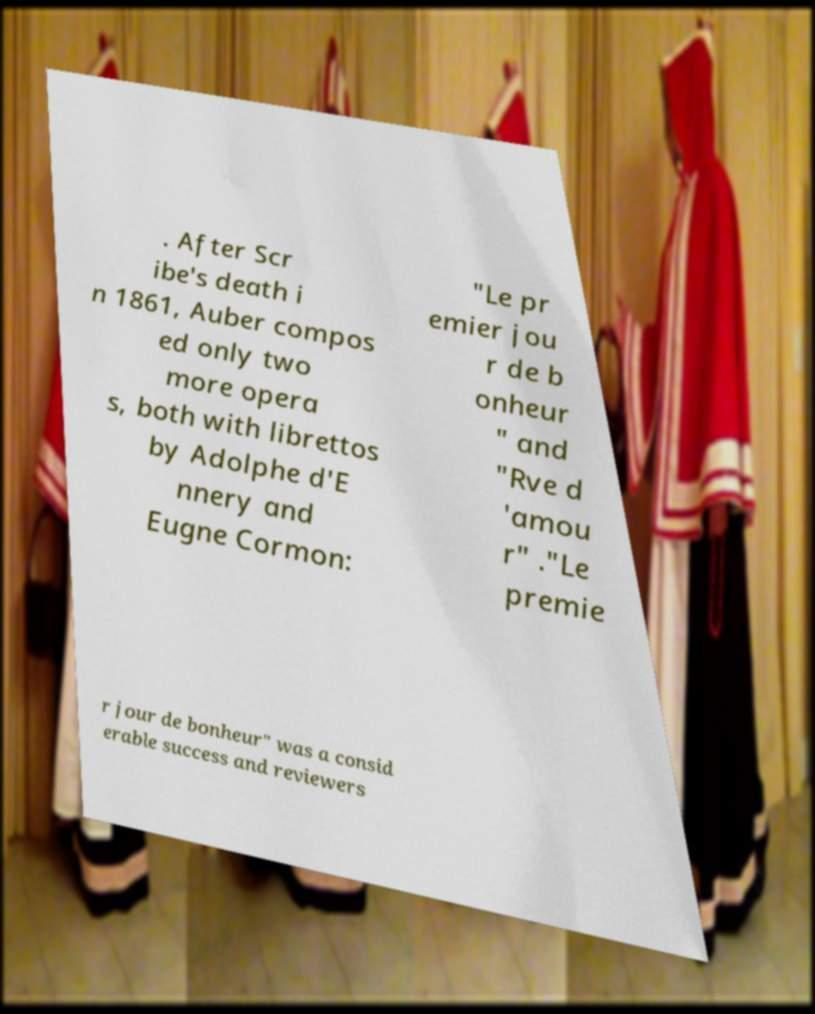Please read and relay the text visible in this image. What does it say? . After Scr ibe's death i n 1861, Auber compos ed only two more opera s, both with librettos by Adolphe d'E nnery and Eugne Cormon: "Le pr emier jou r de b onheur " and "Rve d 'amou r" ."Le premie r jour de bonheur" was a consid erable success and reviewers 